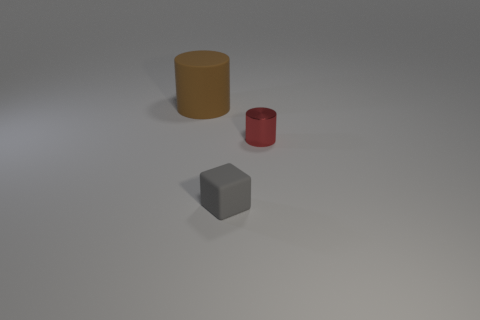Can you describe the lighting in the scene? The lighting in the scene is diffused, coming from above, casting soft shadows directly underneath the objects. The lack of harsh shadows suggests an overcast or neutral light, often used in studio settings to provide even, non-directional light that minimizes glare and hotspots. 